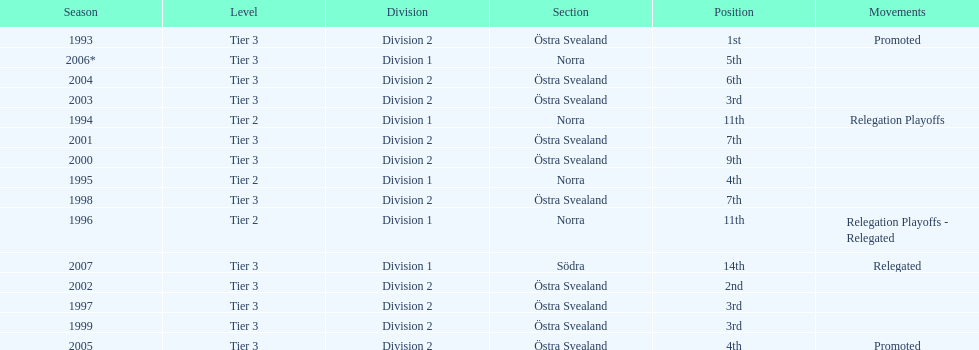How many times did they end up higher than 5th place in division 2 tier 3? 6. 